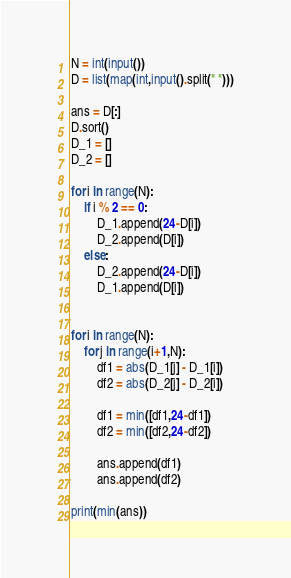Convert code to text. <code><loc_0><loc_0><loc_500><loc_500><_Python_>N = int(input())
D = list(map(int,input().split(" ")))

ans = D[:]
D.sort()
D_1 = []
D_2 = []

for i in range(N):
	if i % 2 == 0:
		D_1.append(24-D[i])
		D_2.append(D[i])
	else:
		D_2.append(24-D[i])
		D_1.append(D[i])


for i in range(N):
	for j in range(i+1,N):
		df1 = abs(D_1[j] - D_1[i])
		df2 = abs(D_2[j] - D_2[i])
		
		df1 = min([df1,24-df1])
		df2 = min([df2,24-df2])
			
		ans.append(df1)
		ans.append(df2)

print(min(ans))




</code> 